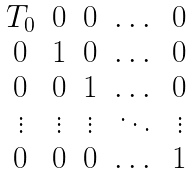Convert formula to latex. <formula><loc_0><loc_0><loc_500><loc_500>\begin{matrix} T _ { 0 } & 0 & 0 & \dots & 0 \\ 0 & 1 & 0 & \dots & 0 \\ 0 & 0 & 1 & \dots & 0 \\ \vdots & \vdots & \vdots & \ddots & \vdots \\ 0 & 0 & 0 & \dots & 1 \end{matrix}</formula> 